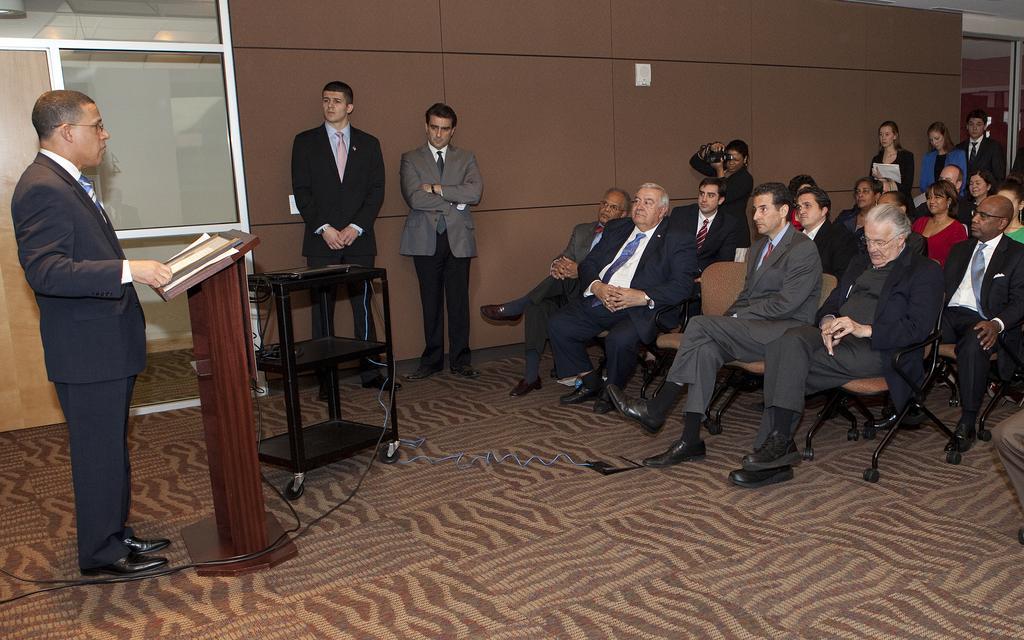Could you give a brief overview of what you see in this image? On the left there is a man standing at the podium and on the podium there is a book. On the right there are few people sitting on the chair. In the background there is a wall,door,glass door,few people standing and in the middle a person is capturing pics and this is a floor. 